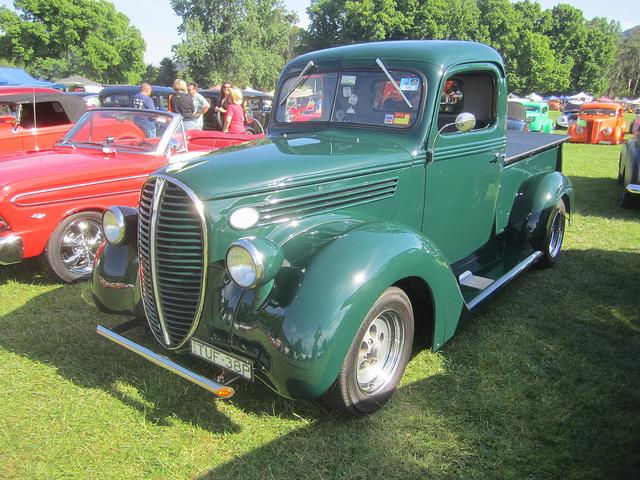Is it nighttime?
Keep it brief. No. What year is the truck?
Concise answer only. 1938. What color is the truck?
Be succinct. Green. 